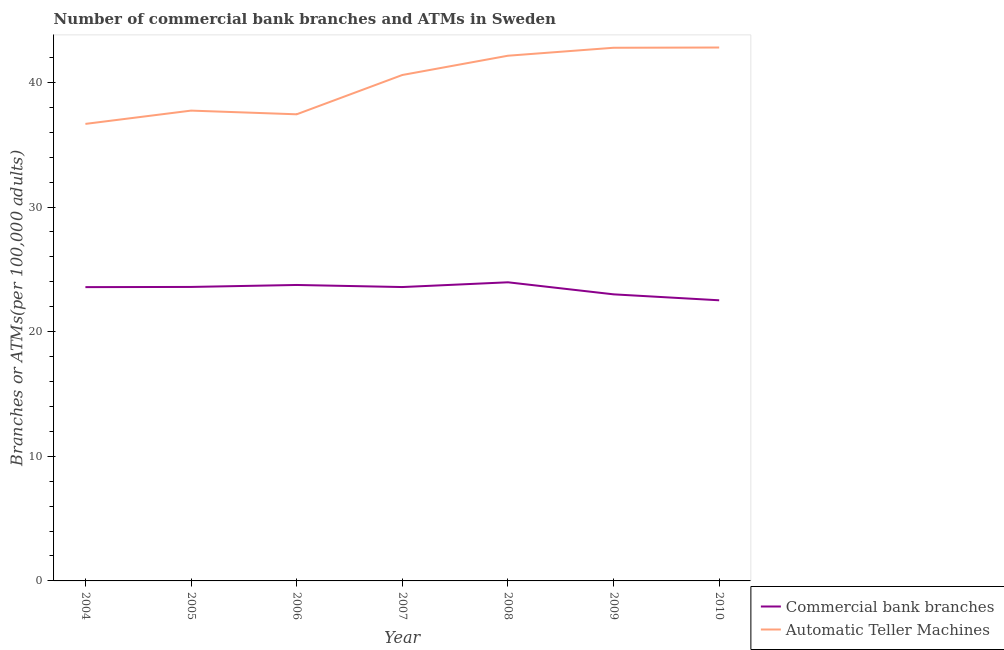Is the number of lines equal to the number of legend labels?
Provide a succinct answer. Yes. What is the number of commercal bank branches in 2004?
Your answer should be compact. 23.57. Across all years, what is the maximum number of commercal bank branches?
Keep it short and to the point. 23.96. Across all years, what is the minimum number of atms?
Offer a terse response. 36.67. In which year was the number of commercal bank branches minimum?
Make the answer very short. 2010. What is the total number of atms in the graph?
Keep it short and to the point. 280.14. What is the difference between the number of atms in 2004 and that in 2006?
Your answer should be very brief. -0.77. What is the difference between the number of commercal bank branches in 2007 and the number of atms in 2010?
Your answer should be compact. -19.22. What is the average number of atms per year?
Ensure brevity in your answer.  40.02. In the year 2006, what is the difference between the number of commercal bank branches and number of atms?
Ensure brevity in your answer.  -13.69. In how many years, is the number of commercal bank branches greater than 24?
Your response must be concise. 0. What is the ratio of the number of commercal bank branches in 2004 to that in 2007?
Your response must be concise. 1. Is the number of atms in 2005 less than that in 2010?
Give a very brief answer. Yes. Is the difference between the number of commercal bank branches in 2006 and 2008 greater than the difference between the number of atms in 2006 and 2008?
Make the answer very short. Yes. What is the difference between the highest and the second highest number of commercal bank branches?
Your answer should be compact. 0.22. What is the difference between the highest and the lowest number of commercal bank branches?
Ensure brevity in your answer.  1.44. Is the number of commercal bank branches strictly greater than the number of atms over the years?
Offer a terse response. No. Is the number of atms strictly less than the number of commercal bank branches over the years?
Ensure brevity in your answer.  No. Does the graph contain grids?
Your answer should be very brief. No. What is the title of the graph?
Offer a very short reply. Number of commercial bank branches and ATMs in Sweden. Does "Fraud firms" appear as one of the legend labels in the graph?
Your answer should be compact. No. What is the label or title of the Y-axis?
Give a very brief answer. Branches or ATMs(per 100,0 adults). What is the Branches or ATMs(per 100,000 adults) in Commercial bank branches in 2004?
Keep it short and to the point. 23.57. What is the Branches or ATMs(per 100,000 adults) of Automatic Teller Machines in 2004?
Your answer should be very brief. 36.67. What is the Branches or ATMs(per 100,000 adults) of Commercial bank branches in 2005?
Your answer should be very brief. 23.59. What is the Branches or ATMs(per 100,000 adults) of Automatic Teller Machines in 2005?
Keep it short and to the point. 37.73. What is the Branches or ATMs(per 100,000 adults) in Commercial bank branches in 2006?
Make the answer very short. 23.74. What is the Branches or ATMs(per 100,000 adults) of Automatic Teller Machines in 2006?
Your answer should be very brief. 37.44. What is the Branches or ATMs(per 100,000 adults) in Commercial bank branches in 2007?
Give a very brief answer. 23.58. What is the Branches or ATMs(per 100,000 adults) of Automatic Teller Machines in 2007?
Your answer should be compact. 40.59. What is the Branches or ATMs(per 100,000 adults) of Commercial bank branches in 2008?
Keep it short and to the point. 23.96. What is the Branches or ATMs(per 100,000 adults) of Automatic Teller Machines in 2008?
Provide a succinct answer. 42.14. What is the Branches or ATMs(per 100,000 adults) of Commercial bank branches in 2009?
Keep it short and to the point. 22.99. What is the Branches or ATMs(per 100,000 adults) in Automatic Teller Machines in 2009?
Keep it short and to the point. 42.78. What is the Branches or ATMs(per 100,000 adults) of Commercial bank branches in 2010?
Ensure brevity in your answer.  22.52. What is the Branches or ATMs(per 100,000 adults) in Automatic Teller Machines in 2010?
Provide a succinct answer. 42.8. Across all years, what is the maximum Branches or ATMs(per 100,000 adults) in Commercial bank branches?
Offer a very short reply. 23.96. Across all years, what is the maximum Branches or ATMs(per 100,000 adults) of Automatic Teller Machines?
Ensure brevity in your answer.  42.8. Across all years, what is the minimum Branches or ATMs(per 100,000 adults) in Commercial bank branches?
Offer a very short reply. 22.52. Across all years, what is the minimum Branches or ATMs(per 100,000 adults) in Automatic Teller Machines?
Provide a short and direct response. 36.67. What is the total Branches or ATMs(per 100,000 adults) of Commercial bank branches in the graph?
Keep it short and to the point. 163.95. What is the total Branches or ATMs(per 100,000 adults) of Automatic Teller Machines in the graph?
Provide a succinct answer. 280.14. What is the difference between the Branches or ATMs(per 100,000 adults) in Commercial bank branches in 2004 and that in 2005?
Keep it short and to the point. -0.01. What is the difference between the Branches or ATMs(per 100,000 adults) in Automatic Teller Machines in 2004 and that in 2005?
Provide a succinct answer. -1.07. What is the difference between the Branches or ATMs(per 100,000 adults) in Commercial bank branches in 2004 and that in 2006?
Keep it short and to the point. -0.17. What is the difference between the Branches or ATMs(per 100,000 adults) in Automatic Teller Machines in 2004 and that in 2006?
Keep it short and to the point. -0.77. What is the difference between the Branches or ATMs(per 100,000 adults) of Commercial bank branches in 2004 and that in 2007?
Keep it short and to the point. -0.01. What is the difference between the Branches or ATMs(per 100,000 adults) in Automatic Teller Machines in 2004 and that in 2007?
Provide a short and direct response. -3.92. What is the difference between the Branches or ATMs(per 100,000 adults) in Commercial bank branches in 2004 and that in 2008?
Give a very brief answer. -0.39. What is the difference between the Branches or ATMs(per 100,000 adults) in Automatic Teller Machines in 2004 and that in 2008?
Your response must be concise. -5.47. What is the difference between the Branches or ATMs(per 100,000 adults) in Commercial bank branches in 2004 and that in 2009?
Keep it short and to the point. 0.58. What is the difference between the Branches or ATMs(per 100,000 adults) in Automatic Teller Machines in 2004 and that in 2009?
Provide a succinct answer. -6.11. What is the difference between the Branches or ATMs(per 100,000 adults) of Commercial bank branches in 2004 and that in 2010?
Provide a short and direct response. 1.06. What is the difference between the Branches or ATMs(per 100,000 adults) in Automatic Teller Machines in 2004 and that in 2010?
Give a very brief answer. -6.13. What is the difference between the Branches or ATMs(per 100,000 adults) in Commercial bank branches in 2005 and that in 2006?
Make the answer very short. -0.16. What is the difference between the Branches or ATMs(per 100,000 adults) of Automatic Teller Machines in 2005 and that in 2006?
Your response must be concise. 0.3. What is the difference between the Branches or ATMs(per 100,000 adults) of Commercial bank branches in 2005 and that in 2007?
Ensure brevity in your answer.  0.01. What is the difference between the Branches or ATMs(per 100,000 adults) of Automatic Teller Machines in 2005 and that in 2007?
Your response must be concise. -2.86. What is the difference between the Branches or ATMs(per 100,000 adults) of Commercial bank branches in 2005 and that in 2008?
Give a very brief answer. -0.37. What is the difference between the Branches or ATMs(per 100,000 adults) in Automatic Teller Machines in 2005 and that in 2008?
Provide a succinct answer. -4.4. What is the difference between the Branches or ATMs(per 100,000 adults) of Commercial bank branches in 2005 and that in 2009?
Offer a terse response. 0.59. What is the difference between the Branches or ATMs(per 100,000 adults) in Automatic Teller Machines in 2005 and that in 2009?
Your answer should be very brief. -5.04. What is the difference between the Branches or ATMs(per 100,000 adults) of Commercial bank branches in 2005 and that in 2010?
Your answer should be very brief. 1.07. What is the difference between the Branches or ATMs(per 100,000 adults) of Automatic Teller Machines in 2005 and that in 2010?
Offer a very short reply. -5.06. What is the difference between the Branches or ATMs(per 100,000 adults) in Commercial bank branches in 2006 and that in 2007?
Your answer should be very brief. 0.17. What is the difference between the Branches or ATMs(per 100,000 adults) in Automatic Teller Machines in 2006 and that in 2007?
Offer a very short reply. -3.15. What is the difference between the Branches or ATMs(per 100,000 adults) of Commercial bank branches in 2006 and that in 2008?
Keep it short and to the point. -0.22. What is the difference between the Branches or ATMs(per 100,000 adults) in Automatic Teller Machines in 2006 and that in 2008?
Ensure brevity in your answer.  -4.7. What is the difference between the Branches or ATMs(per 100,000 adults) in Commercial bank branches in 2006 and that in 2009?
Offer a very short reply. 0.75. What is the difference between the Branches or ATMs(per 100,000 adults) in Automatic Teller Machines in 2006 and that in 2009?
Your response must be concise. -5.34. What is the difference between the Branches or ATMs(per 100,000 adults) in Commercial bank branches in 2006 and that in 2010?
Your response must be concise. 1.23. What is the difference between the Branches or ATMs(per 100,000 adults) of Automatic Teller Machines in 2006 and that in 2010?
Keep it short and to the point. -5.36. What is the difference between the Branches or ATMs(per 100,000 adults) of Commercial bank branches in 2007 and that in 2008?
Make the answer very short. -0.38. What is the difference between the Branches or ATMs(per 100,000 adults) in Automatic Teller Machines in 2007 and that in 2008?
Your answer should be very brief. -1.55. What is the difference between the Branches or ATMs(per 100,000 adults) in Commercial bank branches in 2007 and that in 2009?
Make the answer very short. 0.59. What is the difference between the Branches or ATMs(per 100,000 adults) of Automatic Teller Machines in 2007 and that in 2009?
Your answer should be very brief. -2.19. What is the difference between the Branches or ATMs(per 100,000 adults) of Automatic Teller Machines in 2007 and that in 2010?
Ensure brevity in your answer.  -2.21. What is the difference between the Branches or ATMs(per 100,000 adults) of Commercial bank branches in 2008 and that in 2009?
Provide a short and direct response. 0.97. What is the difference between the Branches or ATMs(per 100,000 adults) of Automatic Teller Machines in 2008 and that in 2009?
Make the answer very short. -0.64. What is the difference between the Branches or ATMs(per 100,000 adults) of Commercial bank branches in 2008 and that in 2010?
Your answer should be compact. 1.44. What is the difference between the Branches or ATMs(per 100,000 adults) of Automatic Teller Machines in 2008 and that in 2010?
Your answer should be very brief. -0.66. What is the difference between the Branches or ATMs(per 100,000 adults) of Commercial bank branches in 2009 and that in 2010?
Keep it short and to the point. 0.48. What is the difference between the Branches or ATMs(per 100,000 adults) of Automatic Teller Machines in 2009 and that in 2010?
Your response must be concise. -0.02. What is the difference between the Branches or ATMs(per 100,000 adults) of Commercial bank branches in 2004 and the Branches or ATMs(per 100,000 adults) of Automatic Teller Machines in 2005?
Make the answer very short. -14.16. What is the difference between the Branches or ATMs(per 100,000 adults) in Commercial bank branches in 2004 and the Branches or ATMs(per 100,000 adults) in Automatic Teller Machines in 2006?
Offer a terse response. -13.87. What is the difference between the Branches or ATMs(per 100,000 adults) in Commercial bank branches in 2004 and the Branches or ATMs(per 100,000 adults) in Automatic Teller Machines in 2007?
Offer a terse response. -17.02. What is the difference between the Branches or ATMs(per 100,000 adults) of Commercial bank branches in 2004 and the Branches or ATMs(per 100,000 adults) of Automatic Teller Machines in 2008?
Your answer should be very brief. -18.57. What is the difference between the Branches or ATMs(per 100,000 adults) in Commercial bank branches in 2004 and the Branches or ATMs(per 100,000 adults) in Automatic Teller Machines in 2009?
Ensure brevity in your answer.  -19.2. What is the difference between the Branches or ATMs(per 100,000 adults) in Commercial bank branches in 2004 and the Branches or ATMs(per 100,000 adults) in Automatic Teller Machines in 2010?
Your answer should be very brief. -19.22. What is the difference between the Branches or ATMs(per 100,000 adults) of Commercial bank branches in 2005 and the Branches or ATMs(per 100,000 adults) of Automatic Teller Machines in 2006?
Your answer should be compact. -13.85. What is the difference between the Branches or ATMs(per 100,000 adults) in Commercial bank branches in 2005 and the Branches or ATMs(per 100,000 adults) in Automatic Teller Machines in 2007?
Offer a very short reply. -17. What is the difference between the Branches or ATMs(per 100,000 adults) in Commercial bank branches in 2005 and the Branches or ATMs(per 100,000 adults) in Automatic Teller Machines in 2008?
Make the answer very short. -18.55. What is the difference between the Branches or ATMs(per 100,000 adults) in Commercial bank branches in 2005 and the Branches or ATMs(per 100,000 adults) in Automatic Teller Machines in 2009?
Offer a very short reply. -19.19. What is the difference between the Branches or ATMs(per 100,000 adults) in Commercial bank branches in 2005 and the Branches or ATMs(per 100,000 adults) in Automatic Teller Machines in 2010?
Your answer should be compact. -19.21. What is the difference between the Branches or ATMs(per 100,000 adults) of Commercial bank branches in 2006 and the Branches or ATMs(per 100,000 adults) of Automatic Teller Machines in 2007?
Keep it short and to the point. -16.85. What is the difference between the Branches or ATMs(per 100,000 adults) of Commercial bank branches in 2006 and the Branches or ATMs(per 100,000 adults) of Automatic Teller Machines in 2008?
Give a very brief answer. -18.39. What is the difference between the Branches or ATMs(per 100,000 adults) of Commercial bank branches in 2006 and the Branches or ATMs(per 100,000 adults) of Automatic Teller Machines in 2009?
Offer a terse response. -19.03. What is the difference between the Branches or ATMs(per 100,000 adults) of Commercial bank branches in 2006 and the Branches or ATMs(per 100,000 adults) of Automatic Teller Machines in 2010?
Make the answer very short. -19.05. What is the difference between the Branches or ATMs(per 100,000 adults) in Commercial bank branches in 2007 and the Branches or ATMs(per 100,000 adults) in Automatic Teller Machines in 2008?
Your response must be concise. -18.56. What is the difference between the Branches or ATMs(per 100,000 adults) in Commercial bank branches in 2007 and the Branches or ATMs(per 100,000 adults) in Automatic Teller Machines in 2009?
Offer a very short reply. -19.2. What is the difference between the Branches or ATMs(per 100,000 adults) in Commercial bank branches in 2007 and the Branches or ATMs(per 100,000 adults) in Automatic Teller Machines in 2010?
Provide a succinct answer. -19.22. What is the difference between the Branches or ATMs(per 100,000 adults) in Commercial bank branches in 2008 and the Branches or ATMs(per 100,000 adults) in Automatic Teller Machines in 2009?
Offer a very short reply. -18.82. What is the difference between the Branches or ATMs(per 100,000 adults) of Commercial bank branches in 2008 and the Branches or ATMs(per 100,000 adults) of Automatic Teller Machines in 2010?
Keep it short and to the point. -18.84. What is the difference between the Branches or ATMs(per 100,000 adults) in Commercial bank branches in 2009 and the Branches or ATMs(per 100,000 adults) in Automatic Teller Machines in 2010?
Make the answer very short. -19.8. What is the average Branches or ATMs(per 100,000 adults) in Commercial bank branches per year?
Your answer should be very brief. 23.42. What is the average Branches or ATMs(per 100,000 adults) of Automatic Teller Machines per year?
Offer a terse response. 40.02. In the year 2004, what is the difference between the Branches or ATMs(per 100,000 adults) of Commercial bank branches and Branches or ATMs(per 100,000 adults) of Automatic Teller Machines?
Your answer should be very brief. -13.1. In the year 2005, what is the difference between the Branches or ATMs(per 100,000 adults) of Commercial bank branches and Branches or ATMs(per 100,000 adults) of Automatic Teller Machines?
Provide a succinct answer. -14.15. In the year 2006, what is the difference between the Branches or ATMs(per 100,000 adults) in Commercial bank branches and Branches or ATMs(per 100,000 adults) in Automatic Teller Machines?
Provide a succinct answer. -13.69. In the year 2007, what is the difference between the Branches or ATMs(per 100,000 adults) in Commercial bank branches and Branches or ATMs(per 100,000 adults) in Automatic Teller Machines?
Keep it short and to the point. -17.01. In the year 2008, what is the difference between the Branches or ATMs(per 100,000 adults) in Commercial bank branches and Branches or ATMs(per 100,000 adults) in Automatic Teller Machines?
Keep it short and to the point. -18.18. In the year 2009, what is the difference between the Branches or ATMs(per 100,000 adults) of Commercial bank branches and Branches or ATMs(per 100,000 adults) of Automatic Teller Machines?
Give a very brief answer. -19.78. In the year 2010, what is the difference between the Branches or ATMs(per 100,000 adults) in Commercial bank branches and Branches or ATMs(per 100,000 adults) in Automatic Teller Machines?
Offer a very short reply. -20.28. What is the ratio of the Branches or ATMs(per 100,000 adults) in Automatic Teller Machines in 2004 to that in 2005?
Provide a short and direct response. 0.97. What is the ratio of the Branches or ATMs(per 100,000 adults) of Commercial bank branches in 2004 to that in 2006?
Provide a succinct answer. 0.99. What is the ratio of the Branches or ATMs(per 100,000 adults) in Automatic Teller Machines in 2004 to that in 2006?
Keep it short and to the point. 0.98. What is the ratio of the Branches or ATMs(per 100,000 adults) of Commercial bank branches in 2004 to that in 2007?
Your answer should be very brief. 1. What is the ratio of the Branches or ATMs(per 100,000 adults) of Automatic Teller Machines in 2004 to that in 2007?
Offer a terse response. 0.9. What is the ratio of the Branches or ATMs(per 100,000 adults) of Commercial bank branches in 2004 to that in 2008?
Make the answer very short. 0.98. What is the ratio of the Branches or ATMs(per 100,000 adults) in Automatic Teller Machines in 2004 to that in 2008?
Offer a very short reply. 0.87. What is the ratio of the Branches or ATMs(per 100,000 adults) of Commercial bank branches in 2004 to that in 2009?
Your answer should be very brief. 1.03. What is the ratio of the Branches or ATMs(per 100,000 adults) of Automatic Teller Machines in 2004 to that in 2009?
Your response must be concise. 0.86. What is the ratio of the Branches or ATMs(per 100,000 adults) of Commercial bank branches in 2004 to that in 2010?
Provide a succinct answer. 1.05. What is the ratio of the Branches or ATMs(per 100,000 adults) in Automatic Teller Machines in 2004 to that in 2010?
Keep it short and to the point. 0.86. What is the ratio of the Branches or ATMs(per 100,000 adults) in Automatic Teller Machines in 2005 to that in 2006?
Provide a short and direct response. 1.01. What is the ratio of the Branches or ATMs(per 100,000 adults) of Automatic Teller Machines in 2005 to that in 2007?
Make the answer very short. 0.93. What is the ratio of the Branches or ATMs(per 100,000 adults) in Commercial bank branches in 2005 to that in 2008?
Provide a short and direct response. 0.98. What is the ratio of the Branches or ATMs(per 100,000 adults) in Automatic Teller Machines in 2005 to that in 2008?
Provide a succinct answer. 0.9. What is the ratio of the Branches or ATMs(per 100,000 adults) in Commercial bank branches in 2005 to that in 2009?
Your response must be concise. 1.03. What is the ratio of the Branches or ATMs(per 100,000 adults) in Automatic Teller Machines in 2005 to that in 2009?
Your answer should be very brief. 0.88. What is the ratio of the Branches or ATMs(per 100,000 adults) in Commercial bank branches in 2005 to that in 2010?
Provide a succinct answer. 1.05. What is the ratio of the Branches or ATMs(per 100,000 adults) of Automatic Teller Machines in 2005 to that in 2010?
Your answer should be very brief. 0.88. What is the ratio of the Branches or ATMs(per 100,000 adults) of Commercial bank branches in 2006 to that in 2007?
Keep it short and to the point. 1.01. What is the ratio of the Branches or ATMs(per 100,000 adults) of Automatic Teller Machines in 2006 to that in 2007?
Your answer should be compact. 0.92. What is the ratio of the Branches or ATMs(per 100,000 adults) of Automatic Teller Machines in 2006 to that in 2008?
Ensure brevity in your answer.  0.89. What is the ratio of the Branches or ATMs(per 100,000 adults) of Commercial bank branches in 2006 to that in 2009?
Your answer should be compact. 1.03. What is the ratio of the Branches or ATMs(per 100,000 adults) in Automatic Teller Machines in 2006 to that in 2009?
Make the answer very short. 0.88. What is the ratio of the Branches or ATMs(per 100,000 adults) in Commercial bank branches in 2006 to that in 2010?
Provide a succinct answer. 1.05. What is the ratio of the Branches or ATMs(per 100,000 adults) of Automatic Teller Machines in 2006 to that in 2010?
Your answer should be very brief. 0.87. What is the ratio of the Branches or ATMs(per 100,000 adults) in Commercial bank branches in 2007 to that in 2008?
Give a very brief answer. 0.98. What is the ratio of the Branches or ATMs(per 100,000 adults) in Automatic Teller Machines in 2007 to that in 2008?
Your answer should be compact. 0.96. What is the ratio of the Branches or ATMs(per 100,000 adults) of Commercial bank branches in 2007 to that in 2009?
Provide a succinct answer. 1.03. What is the ratio of the Branches or ATMs(per 100,000 adults) of Automatic Teller Machines in 2007 to that in 2009?
Keep it short and to the point. 0.95. What is the ratio of the Branches or ATMs(per 100,000 adults) in Commercial bank branches in 2007 to that in 2010?
Offer a very short reply. 1.05. What is the ratio of the Branches or ATMs(per 100,000 adults) in Automatic Teller Machines in 2007 to that in 2010?
Your answer should be very brief. 0.95. What is the ratio of the Branches or ATMs(per 100,000 adults) of Commercial bank branches in 2008 to that in 2009?
Your response must be concise. 1.04. What is the ratio of the Branches or ATMs(per 100,000 adults) in Automatic Teller Machines in 2008 to that in 2009?
Keep it short and to the point. 0.99. What is the ratio of the Branches or ATMs(per 100,000 adults) in Commercial bank branches in 2008 to that in 2010?
Offer a terse response. 1.06. What is the ratio of the Branches or ATMs(per 100,000 adults) in Automatic Teller Machines in 2008 to that in 2010?
Offer a very short reply. 0.98. What is the ratio of the Branches or ATMs(per 100,000 adults) of Commercial bank branches in 2009 to that in 2010?
Your response must be concise. 1.02. What is the difference between the highest and the second highest Branches or ATMs(per 100,000 adults) in Commercial bank branches?
Offer a very short reply. 0.22. What is the difference between the highest and the second highest Branches or ATMs(per 100,000 adults) of Automatic Teller Machines?
Offer a very short reply. 0.02. What is the difference between the highest and the lowest Branches or ATMs(per 100,000 adults) in Commercial bank branches?
Your answer should be very brief. 1.44. What is the difference between the highest and the lowest Branches or ATMs(per 100,000 adults) in Automatic Teller Machines?
Make the answer very short. 6.13. 